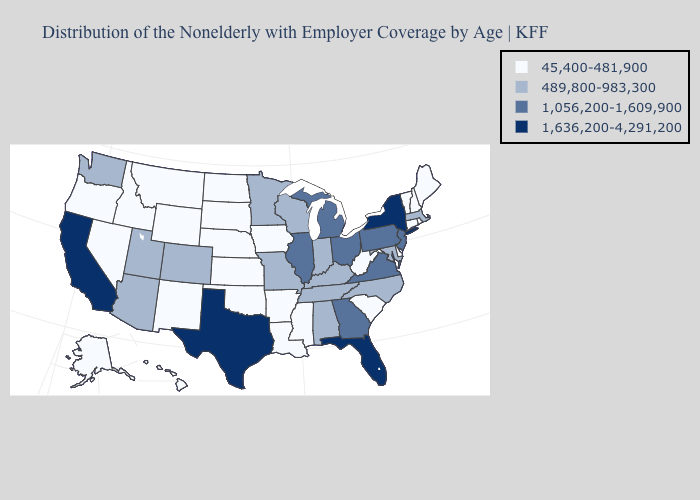What is the value of Virginia?
Concise answer only. 1,056,200-1,609,900. Which states have the lowest value in the Northeast?
Answer briefly. Connecticut, Maine, New Hampshire, Rhode Island, Vermont. Does Nebraska have the highest value in the MidWest?
Short answer required. No. What is the highest value in the MidWest ?
Concise answer only. 1,056,200-1,609,900. Name the states that have a value in the range 45,400-481,900?
Answer briefly. Alaska, Arkansas, Connecticut, Delaware, Hawaii, Idaho, Iowa, Kansas, Louisiana, Maine, Mississippi, Montana, Nebraska, Nevada, New Hampshire, New Mexico, North Dakota, Oklahoma, Oregon, Rhode Island, South Carolina, South Dakota, Vermont, West Virginia, Wyoming. Does Iowa have the lowest value in the MidWest?
Answer briefly. Yes. What is the lowest value in the USA?
Give a very brief answer. 45,400-481,900. Among the states that border Washington , which have the lowest value?
Be succinct. Idaho, Oregon. What is the value of Kentucky?
Keep it brief. 489,800-983,300. Name the states that have a value in the range 45,400-481,900?
Quick response, please. Alaska, Arkansas, Connecticut, Delaware, Hawaii, Idaho, Iowa, Kansas, Louisiana, Maine, Mississippi, Montana, Nebraska, Nevada, New Hampshire, New Mexico, North Dakota, Oklahoma, Oregon, Rhode Island, South Carolina, South Dakota, Vermont, West Virginia, Wyoming. Name the states that have a value in the range 1,056,200-1,609,900?
Concise answer only. Georgia, Illinois, Michigan, New Jersey, Ohio, Pennsylvania, Virginia. Name the states that have a value in the range 1,056,200-1,609,900?
Give a very brief answer. Georgia, Illinois, Michigan, New Jersey, Ohio, Pennsylvania, Virginia. Name the states that have a value in the range 1,636,200-4,291,200?
Be succinct. California, Florida, New York, Texas. Name the states that have a value in the range 1,056,200-1,609,900?
Short answer required. Georgia, Illinois, Michigan, New Jersey, Ohio, Pennsylvania, Virginia. 